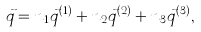Convert formula to latex. <formula><loc_0><loc_0><loc_500><loc_500>\vec { q } = n _ { 1 } \vec { q } ^ { ( 1 ) } + n _ { 2 } \vec { q } ^ { ( 2 ) } + n _ { 3 } \vec { q } ^ { ( 3 ) } ,</formula> 